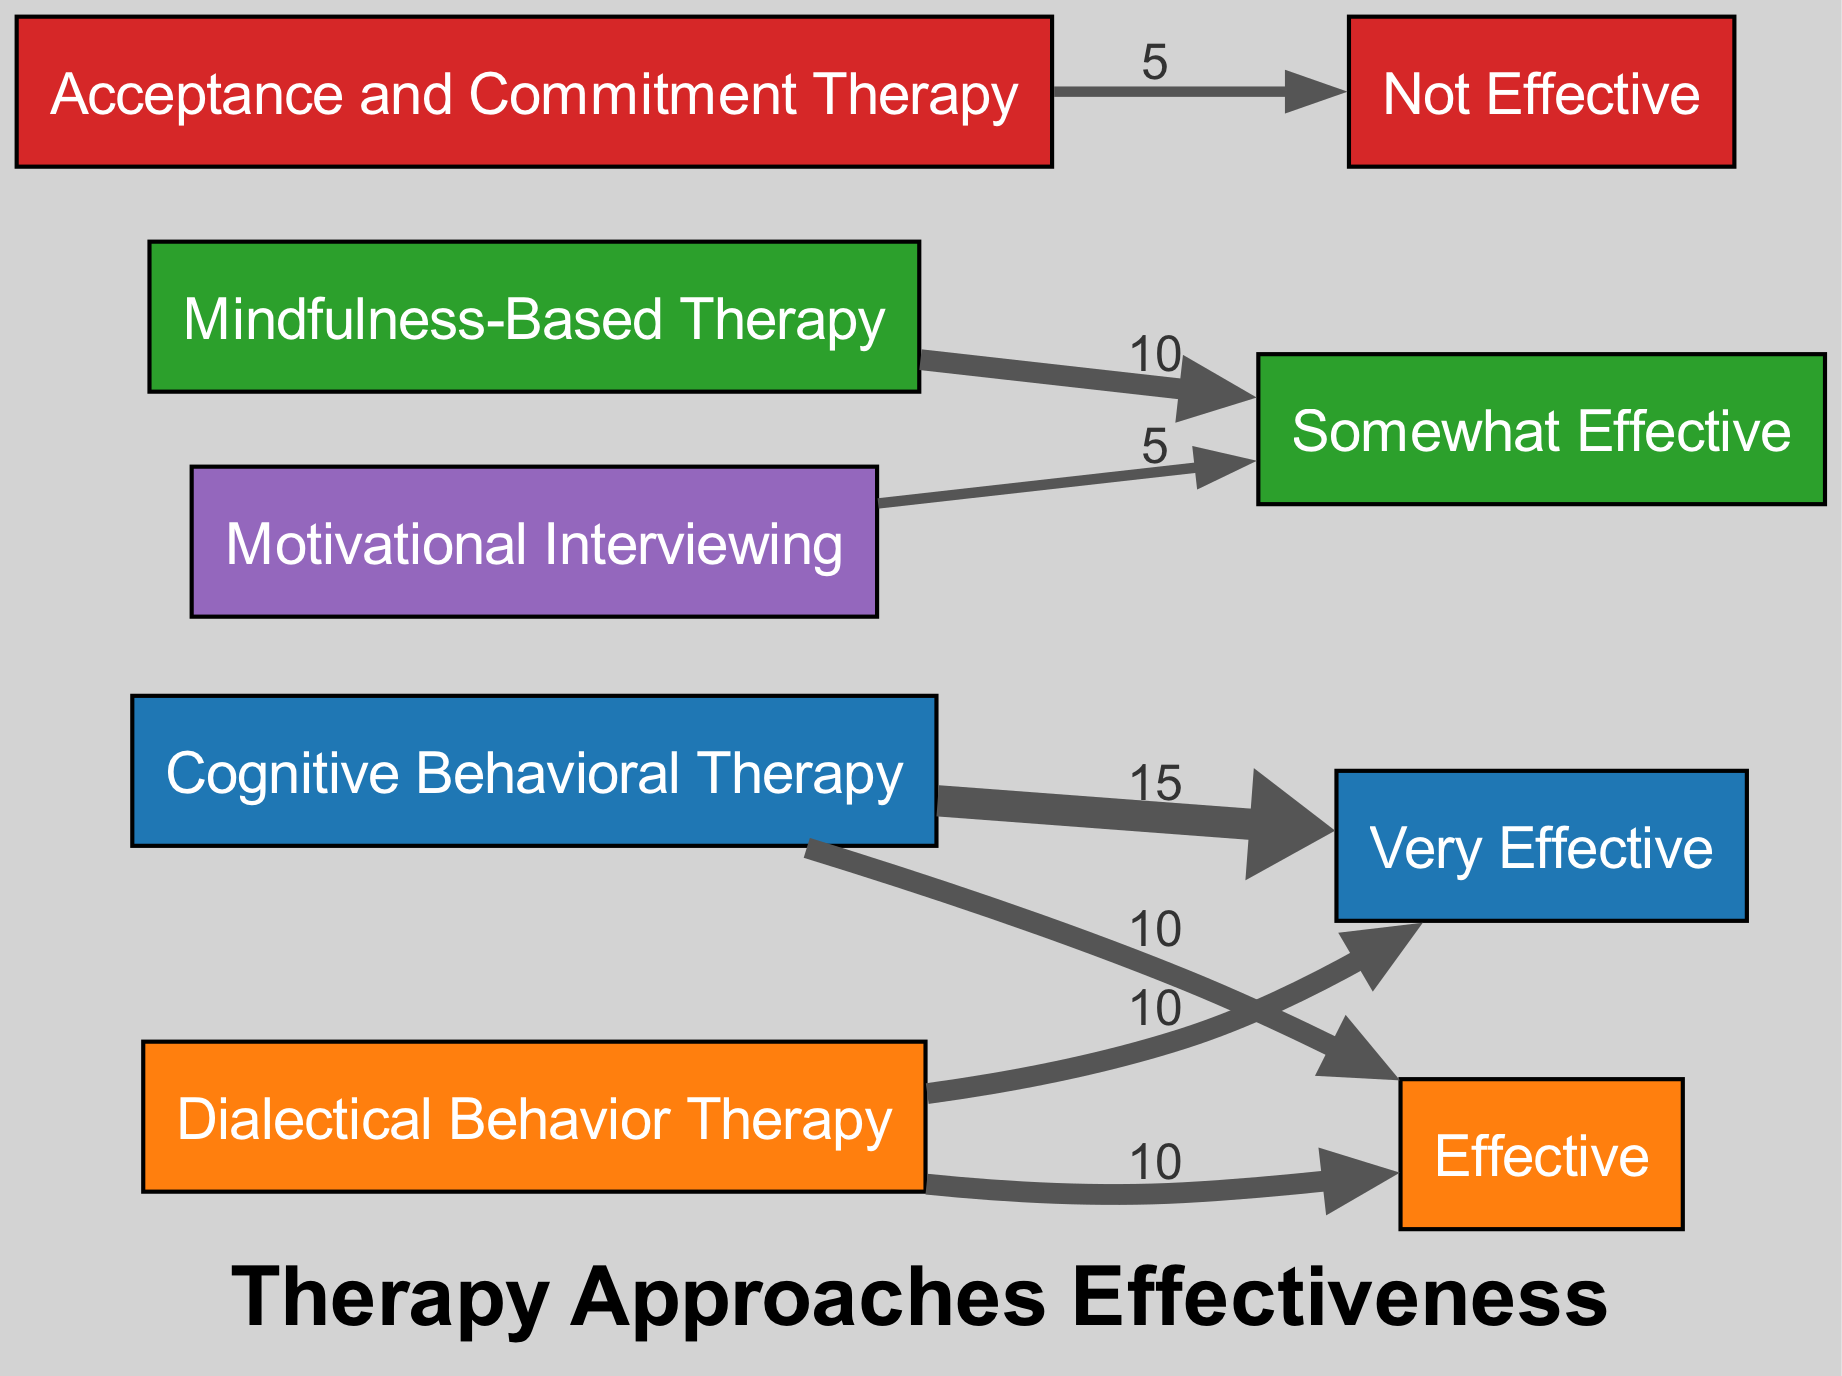What is the total value of feedback categorized as "Very Effective"? To find the total value for "Very Effective," we look at the corresponding flows from the therapy approaches. The flows are from Cognitive Behavioral Therapy (15) and Dialectical Behavior Therapy (10), totaling 15 + 10 = 25.
Answer: 25 How many therapy approaches are represented in this diagram? The diagram contains five distinct therapy approaches: Cognitive Behavioral Therapy, Dialectical Behavior Therapy, Mindfulness-Based Therapy, Acceptance and Commitment Therapy, and Motivational Interviewing. Counting these gives us a total of five therapy approaches.
Answer: 5 Which therapy approach received the highest feedback under "Effective"? We analyze the flow to the "Effective" category. Cognitive Behavioral Therapy (10) and Dialectical Behavior Therapy (10) are tied, both receiving the same maximum amount. Since multiple approaches received this feedback score, we note that they share the highest rating.
Answer: Cognitive Behavioral Therapy, Dialectical Behavior Therapy What is the value associated with "Not Effective"? To identify the value for "Not Effective," we refer directly to the target node labeled "Not Effective," which has a value of 10 as shown in the diagram.
Answer: 10 Which therapy approach has the lowest total value of feedback? Reviewing the flows, Acceptance and Commitment Therapy has a flow to "Not Effective" (5) and does not have any other positive feedback, giving it the lowest total value of feedback among the approaches.
Answer: Acceptance and Commitment Therapy How much total feedback is categorized as "Somewhat Effective"? The "Somewhat Effective" category has flows from Mindfulness-Based Therapy (10) and Motivational Interviewing (5), adding these gives us a total of 10 + 5 = 15 for that category.
Answer: 15 Which feedback category has the lowest total value? Evaluating the edges connecting to each feedback category, the "Not Effective" category has the least flow value with a total of 10, indicating it is the lowest feedback category on the diagram.
Answer: Not Effective What is the total combined value for "Effective" feedback? To compute the total for "Effective," we sum the feedback values that connect to it, which come from Cognitive Behavioral Therapy (10) and Dialectical Behavior Therapy (10), resulting in 10 + 10 = 20 for combined "Effective" feedback.
Answer: 20 How many feedback types are there in the diagram? The diagram lists four types of feedback categories: Very Effective, Effective, Somewhat Effective, and Not Effective. Thus, we can verify that there are four different feedback types represented.
Answer: 4 